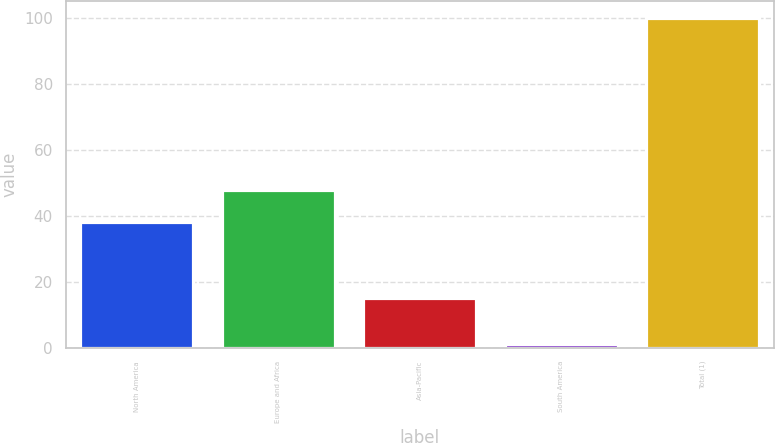<chart> <loc_0><loc_0><loc_500><loc_500><bar_chart><fcel>North America<fcel>Europe and Africa<fcel>Asia-Pacific<fcel>South America<fcel>Total (1)<nl><fcel>38<fcel>47.9<fcel>15<fcel>1<fcel>100<nl></chart> 